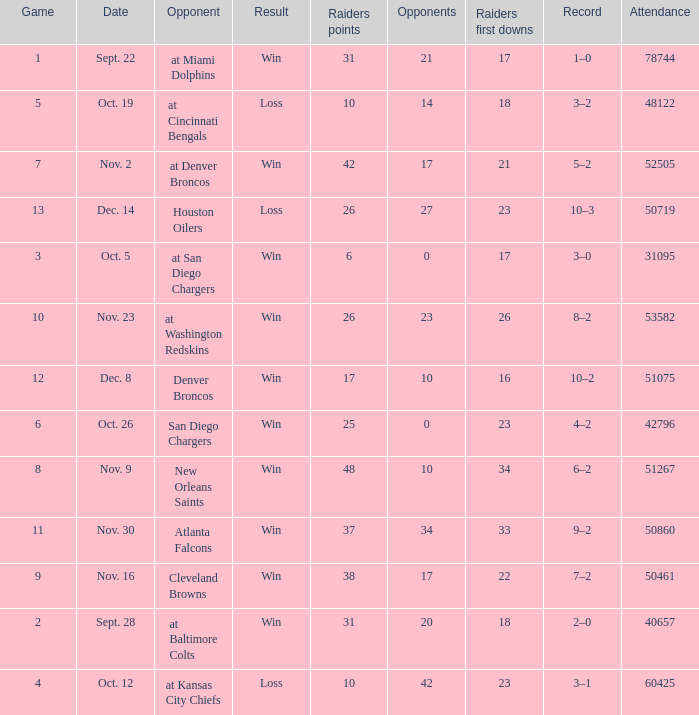How many different counts of the Raiders first downs are there for the game number 9? 1.0. 